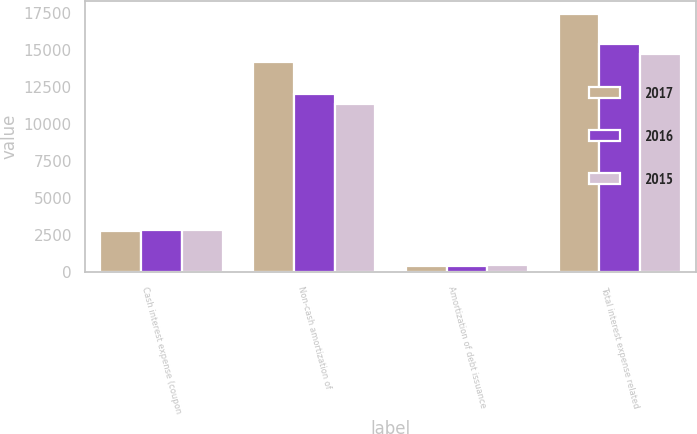Convert chart to OTSL. <chart><loc_0><loc_0><loc_500><loc_500><stacked_bar_chart><ecel><fcel>Cash interest expense (coupon<fcel>Non-cash amortization of<fcel>Amortization of debt issuance<fcel>Total interest expense related<nl><fcel>2017<fcel>2784<fcel>14221<fcel>453<fcel>17458<nl><fcel>2016<fcel>2875<fcel>12085<fcel>443<fcel>15403<nl><fcel>2015<fcel>2875<fcel>11387<fcel>466<fcel>14728<nl></chart> 